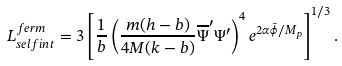<formula> <loc_0><loc_0><loc_500><loc_500>L _ { s e l f i n t } ^ { f e r m } = 3 \left [ \frac { 1 } { b } \left ( \frac { m ( h - b ) } { 4 M ( k - b ) } \overline { \Psi } ^ { \prime } \Psi ^ { \prime } \right ) ^ { 4 } e ^ { 2 \alpha \bar { \phi } / M _ { p } } \right ] ^ { 1 / 3 } .</formula> 